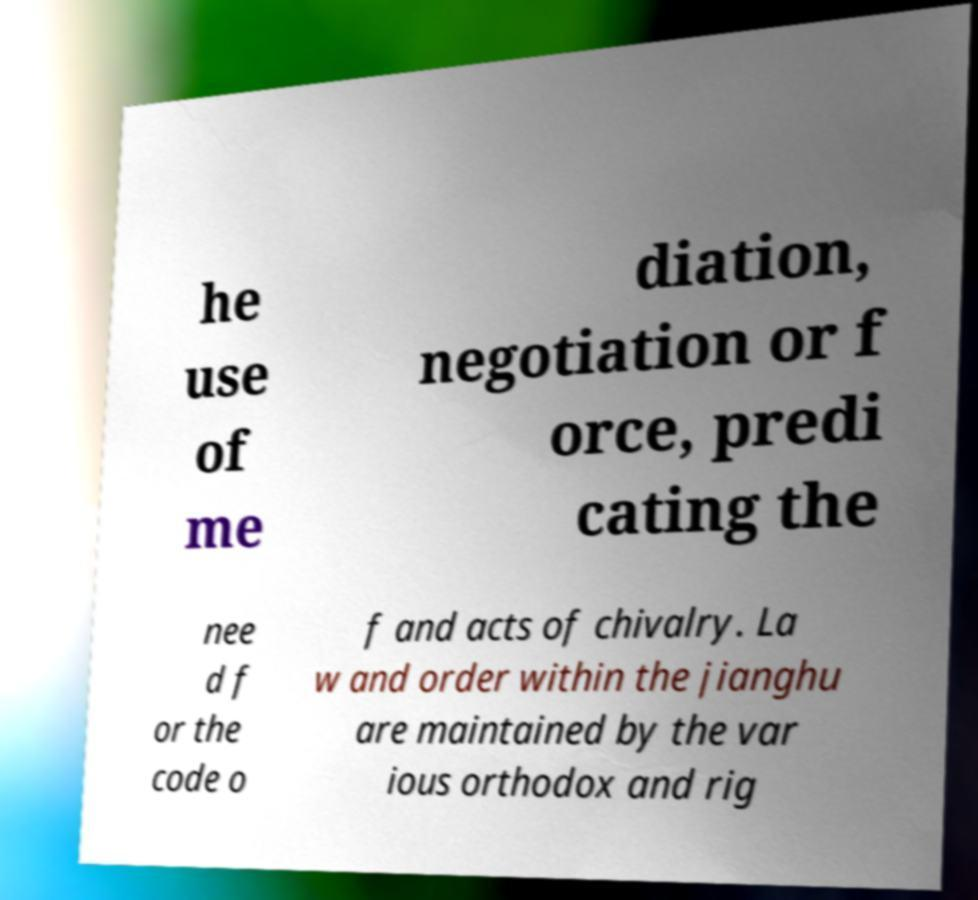I need the written content from this picture converted into text. Can you do that? he use of me diation, negotiation or f orce, predi cating the nee d f or the code o f and acts of chivalry. La w and order within the jianghu are maintained by the var ious orthodox and rig 